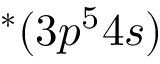Convert formula to latex. <formula><loc_0><loc_0><loc_500><loc_500>^ { * } ( 3 p ^ { 5 } 4 s )</formula> 